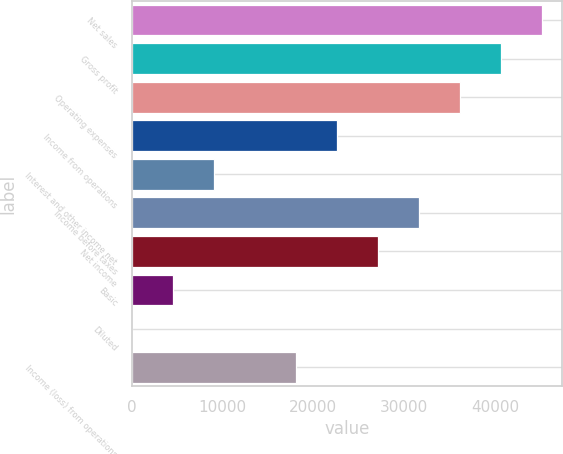Convert chart. <chart><loc_0><loc_0><loc_500><loc_500><bar_chart><fcel>Net sales<fcel>Gross profit<fcel>Operating expenses<fcel>Income from operations<fcel>Interest and other income net<fcel>Income before taxes<fcel>Net income<fcel>Basic<fcel>Diluted<fcel>Income (loss) from operations<nl><fcel>45194<fcel>40674.7<fcel>36155.3<fcel>22597.2<fcel>9039.06<fcel>31635.9<fcel>27116.5<fcel>4519.69<fcel>0.32<fcel>18077.8<nl></chart> 